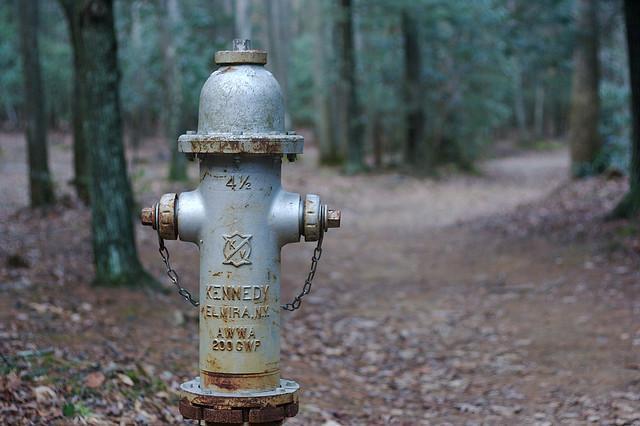How many people are walking?
Give a very brief answer. 0. 